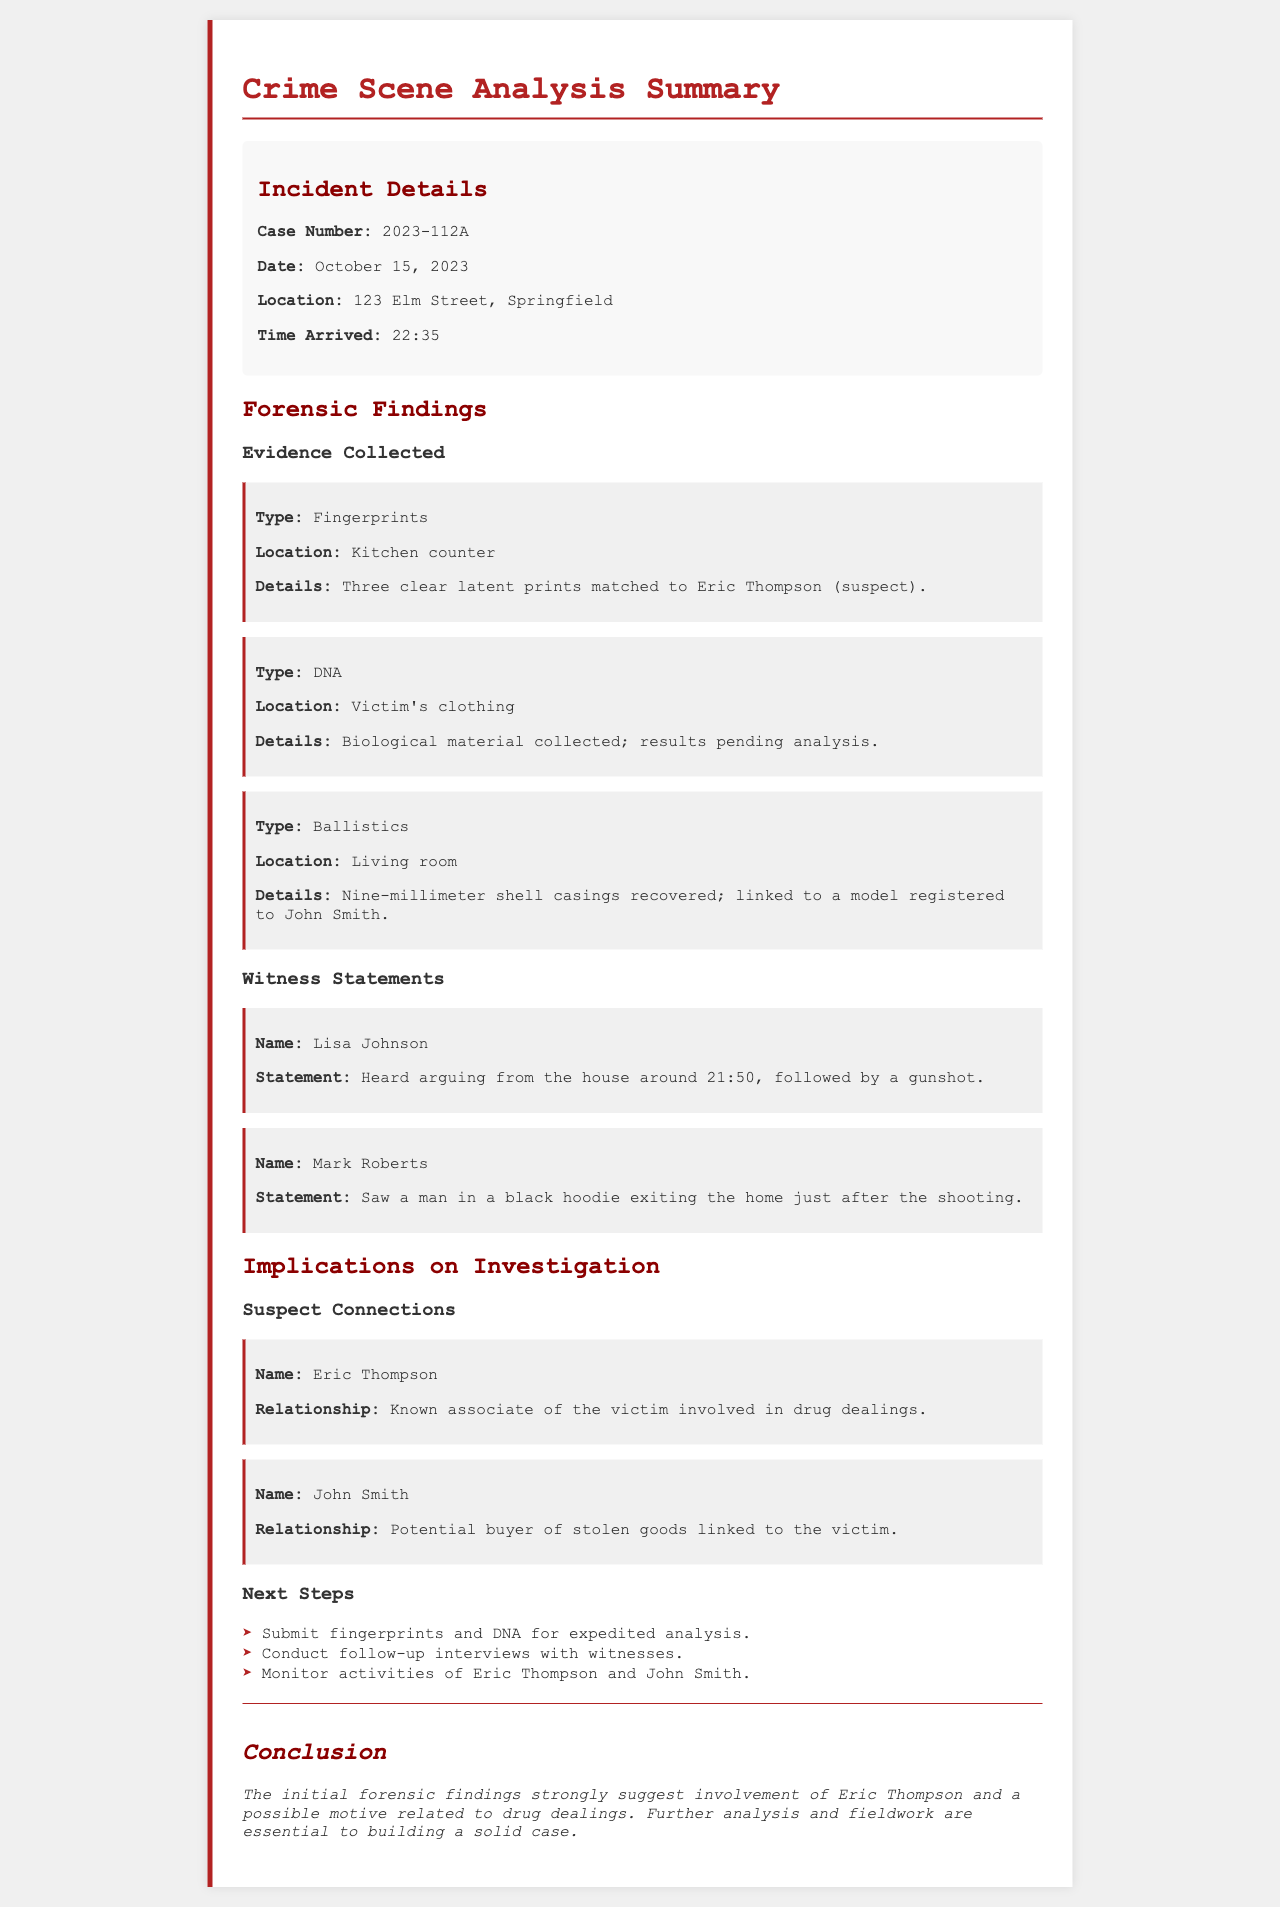What is the case number? The case number is outlined in the incident details section.
Answer: 2023-112A What type of evidence was found on the kitchen counter? The type of evidence is specified in the forensic findings section.
Answer: Fingerprints What was the relationship of Eric Thompson to the victim? Eric Thompson's relationship to the victim is described in the suspect connections section.
Answer: Known associate in drug dealings How many shell casings were recovered? The number of shell casings recovered is stated in the ballistics evidence section.
Answer: Nine Who heard arguing from the house? The witness's name is mentioned in the witness statements section.
Answer: Lisa Johnson What is pending analysis related to the victim's clothing? The forensic findings section indicates what is pending analysis.
Answer: DNA What was the time of the incident? The time of the incident is noted in the incident details section.
Answer: 21:50 What should be submitted for expedited analysis? The next steps outline what should be submitted for analysis.
Answer: Fingerprints and DNA 